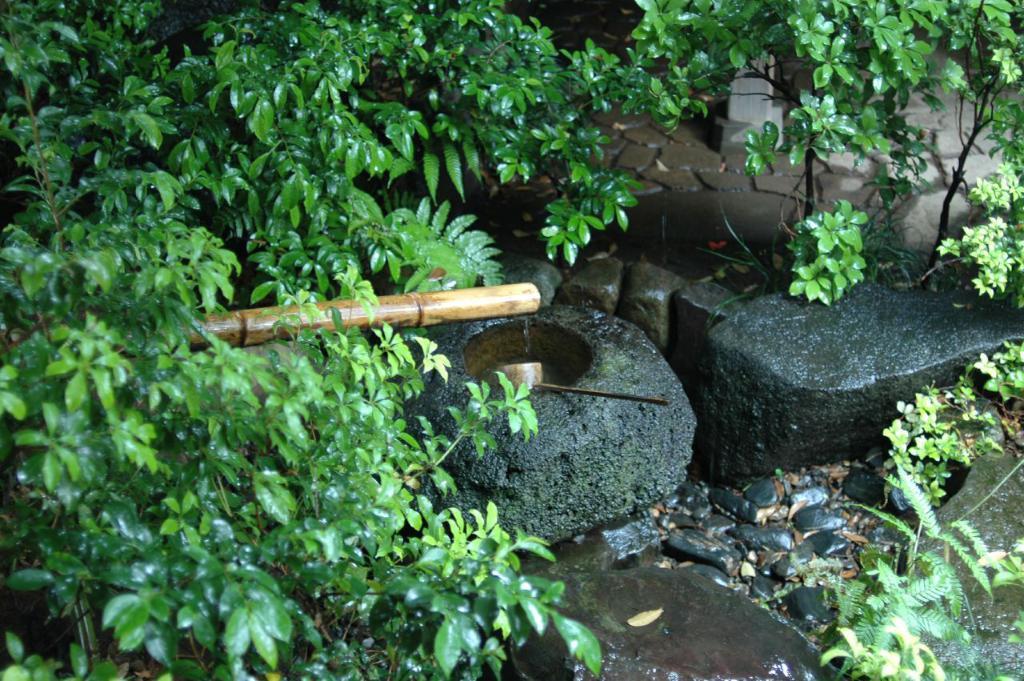Can you describe this image briefly? This picture is clicked outside. In the center we can see the rocks and a wooden hammer and some objects and we can see the plants and the green leaves. In the background we can see the pavement and some objects. 